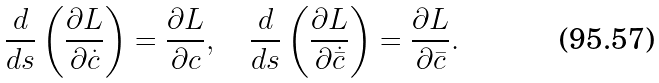<formula> <loc_0><loc_0><loc_500><loc_500>\frac { d } { d s } \left ( \frac { \partial L } { \partial \dot { c } } \right ) = \frac { \partial L } { \partial c } , \quad \frac { d } { d s } \left ( \frac { \partial L } { \partial \dot { \bar { c } } } \right ) = \frac { \partial L } { \partial \bar { c } } .</formula> 